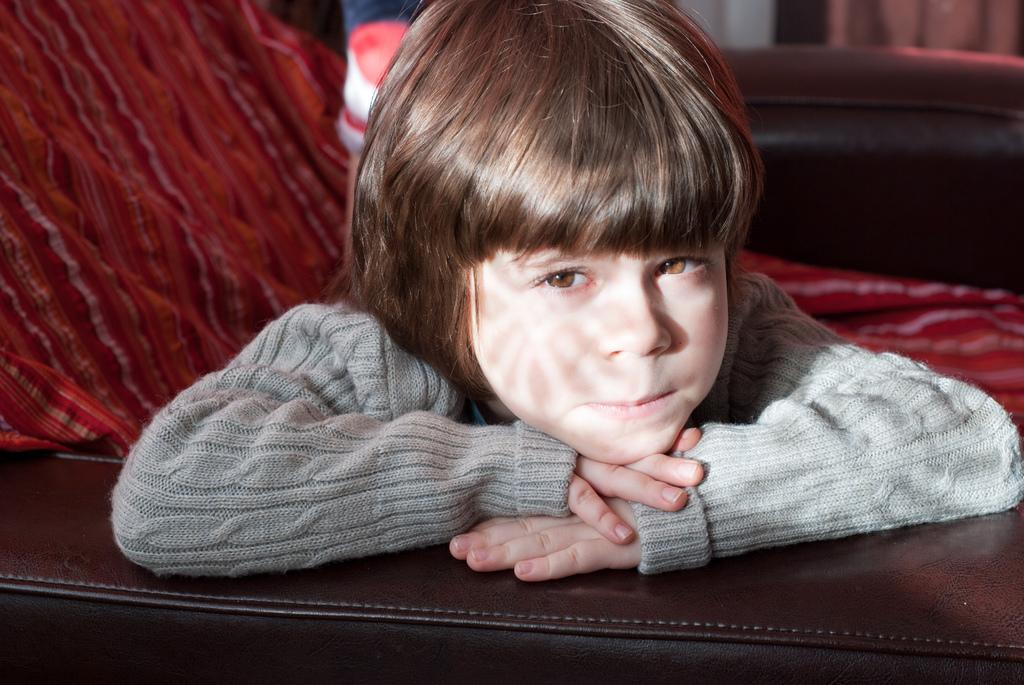What is the main subject of the image? The main subject of the image is a child. What is the child doing in the image? The child is sitting in a chair. What color cloth is present in the image? There is a red color cloth in the image. Where is the red color cloth placed in the image? The red color cloth is kept on a chair. What type of milk is being discussed in the committee meeting in the image? There is no committee meeting or milk present in the image. How many quartz crystals can be seen on the chair in the image? There are no quartz crystals present in the image. 